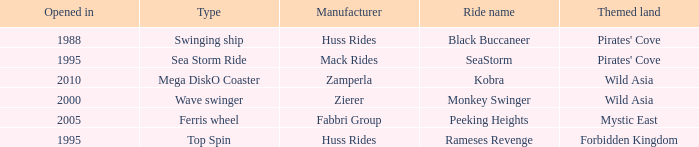Which ride opened after the 2000 Peeking Heights? Ferris wheel. 